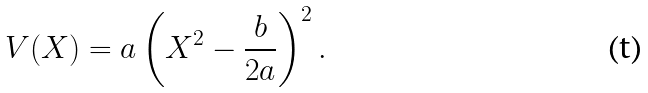<formula> <loc_0><loc_0><loc_500><loc_500>V ( X ) = a \left ( X ^ { 2 } - \frac { b } { 2 a } \right ) ^ { 2 } .</formula> 